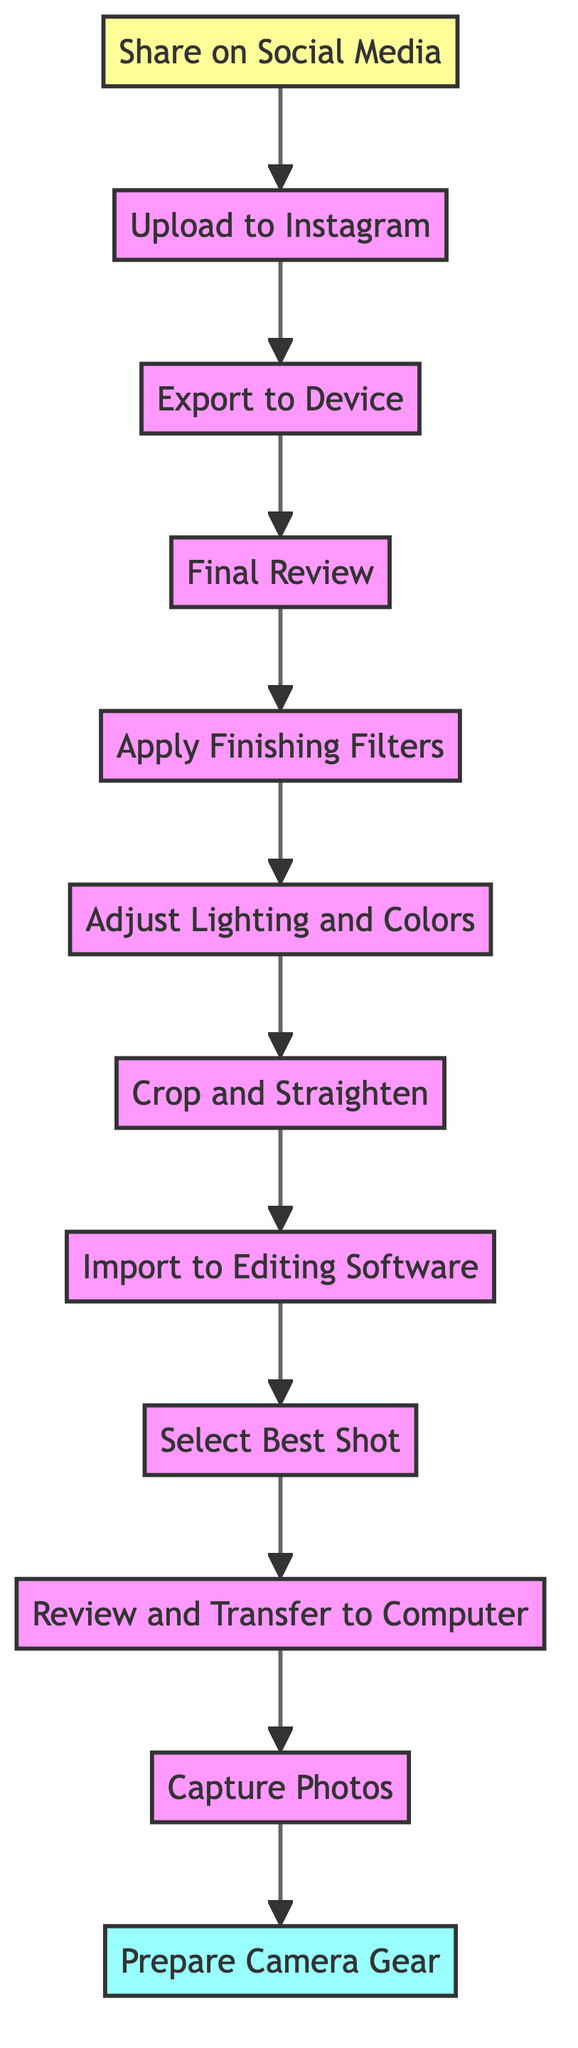What is the first step in the workflow? The diagram indicates that the first step is "Prepare Camera Gear," as it is positioned at the top of the flowchart.
Answer: Prepare Camera Gear How many steps are involved in the editing and sharing workflow? Counting the steps listed from "Capture Photos" to "Upload to Instagram," there are a total of 10 steps.
Answer: 10 What is the last action before sharing on social media? The last action before "Share on Social Media" is "Upload to Instagram," as it directly precedes it in the workflow.
Answer: Upload to Instagram Which step involves enhancing the photo’s aesthetics? The step labeled "Apply Finishing Filters" specifically mentions adding final filters to improve aesthetics.
Answer: Apply Finishing Filters What are the two steps directly before "Final Review"? The two steps before "Final Review" are "Apply Finishing Filters" and "Adjust Lighting and Colors," as indicated on the flowchart.
Answer: Apply Finishing Filters, Adjust Lighting and Colors Which step comes after "Review and Transfer to Computer"? The workflow indicates that after "Review and Transfer to Computer," the next step is "Select Best Shot."
Answer: Select Best Shot Which step is placed directly below "Export to Device"? The step directly below "Export to Device" is "Final Review," as they are sequential in the chart.
Answer: Final Review What is the description of the "Crop and Straighten" step? The description states to "Trim the edges and align the photo for better composition," which is the function of the "Crop and Straighten" step.
Answer: Trim the edges and align the photo for better composition What step involves taking multiple shots? The step named "Capture Photos" discusses taking various shots to experiment with different compositions and settings.
Answer: Capture Photos What is the immediate previous step to "Import to Editing Software"? The immediate previous step to "Import to Editing Software" is "Select Best Shot," as indicated in the flow of the diagram.
Answer: Select Best Shot 